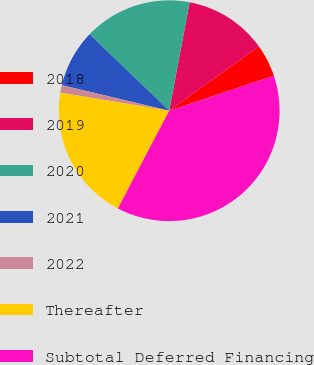Convert chart to OTSL. <chart><loc_0><loc_0><loc_500><loc_500><pie_chart><fcel>2018<fcel>2019<fcel>2020<fcel>2021<fcel>2022<fcel>Thereafter<fcel>Subtotal Deferred Financing<nl><fcel>4.78%<fcel>12.12%<fcel>15.8%<fcel>8.45%<fcel>1.11%<fcel>19.92%<fcel>37.83%<nl></chart> 